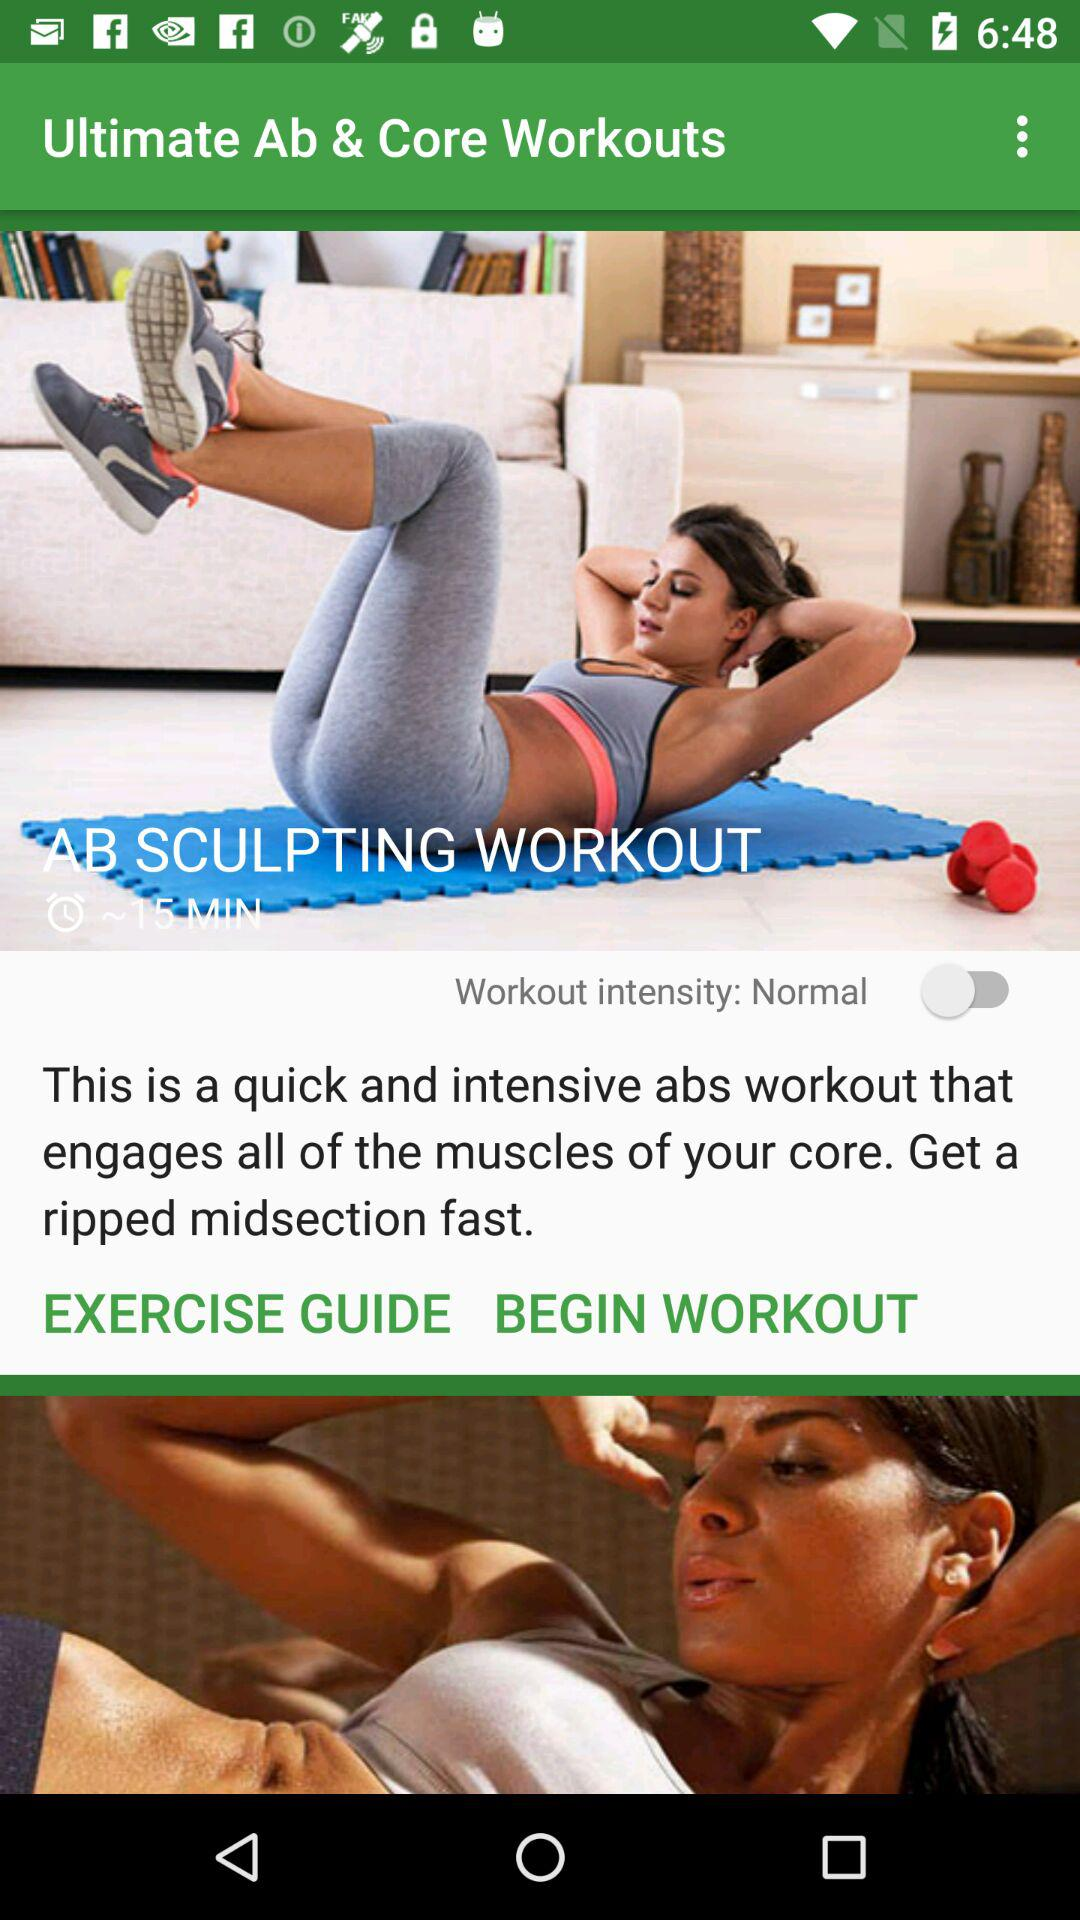What is the application name? The application name is "Ultimate Ab & Core Workouts". 